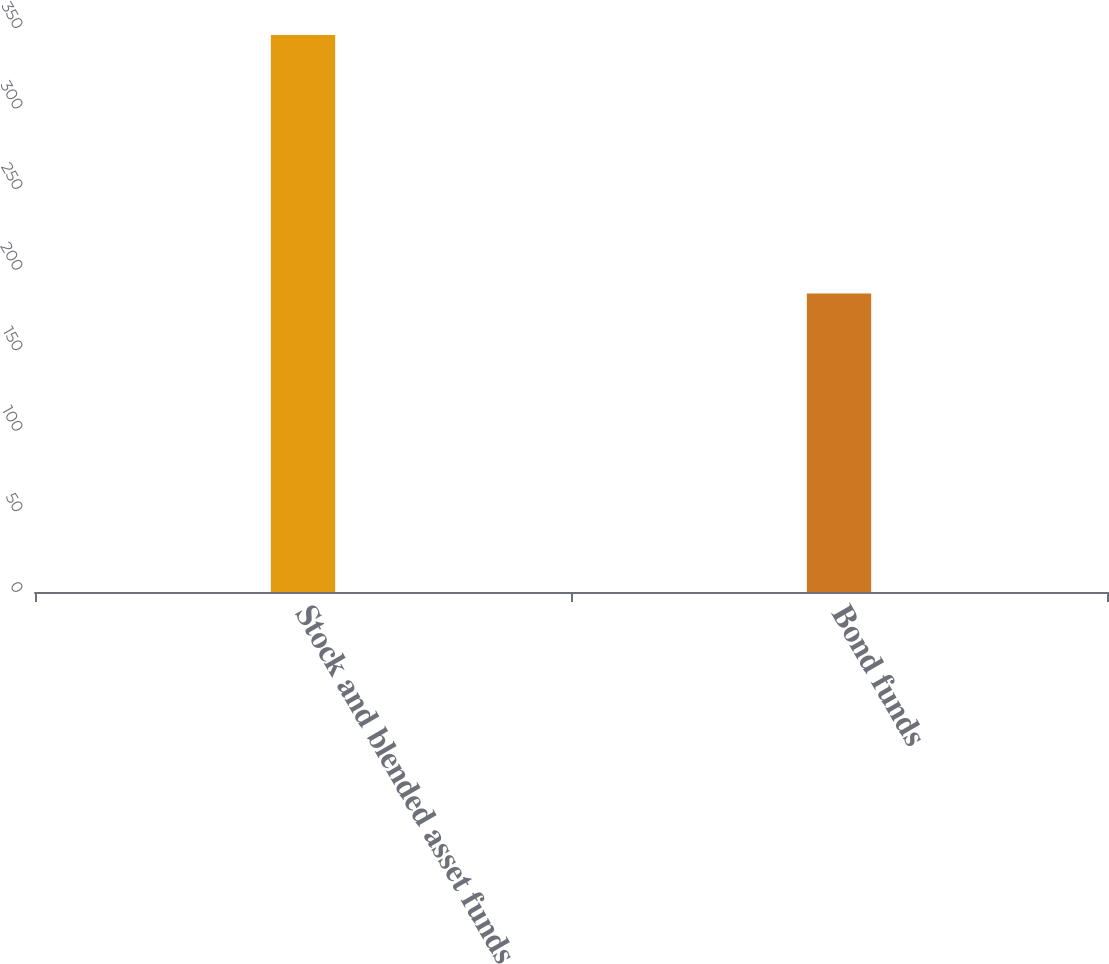Convert chart. <chart><loc_0><loc_0><loc_500><loc_500><bar_chart><fcel>Stock and blended asset funds<fcel>Bond funds<nl><fcel>345.7<fcel>185.3<nl></chart> 